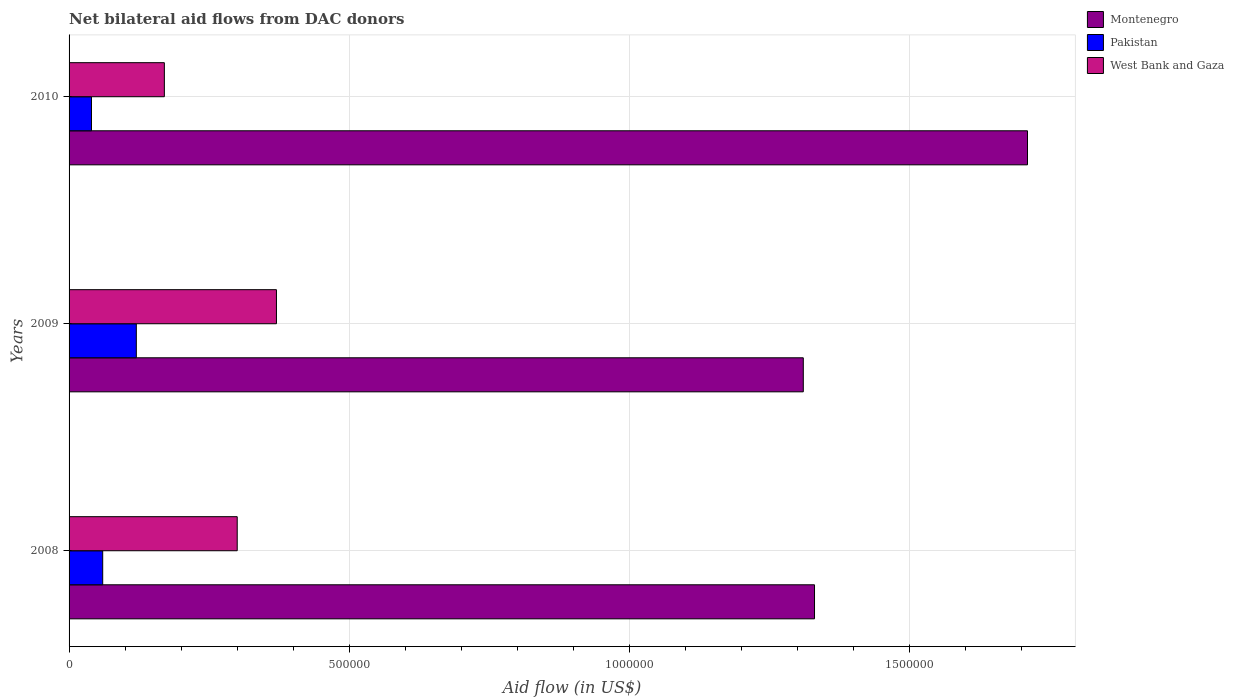How many groups of bars are there?
Offer a terse response. 3. Are the number of bars per tick equal to the number of legend labels?
Give a very brief answer. Yes. Are the number of bars on each tick of the Y-axis equal?
Offer a terse response. Yes. How many bars are there on the 3rd tick from the top?
Your response must be concise. 3. In how many cases, is the number of bars for a given year not equal to the number of legend labels?
Offer a very short reply. 0. What is the net bilateral aid flow in West Bank and Gaza in 2010?
Make the answer very short. 1.70e+05. Across all years, what is the maximum net bilateral aid flow in West Bank and Gaza?
Your answer should be compact. 3.70e+05. Across all years, what is the minimum net bilateral aid flow in Pakistan?
Your answer should be compact. 4.00e+04. In which year was the net bilateral aid flow in Pakistan maximum?
Offer a terse response. 2009. In which year was the net bilateral aid flow in West Bank and Gaza minimum?
Your response must be concise. 2010. What is the difference between the net bilateral aid flow in Pakistan in 2010 and the net bilateral aid flow in Montenegro in 2008?
Your answer should be very brief. -1.29e+06. What is the average net bilateral aid flow in Montenegro per year?
Your answer should be compact. 1.45e+06. In the year 2010, what is the difference between the net bilateral aid flow in West Bank and Gaza and net bilateral aid flow in Montenegro?
Give a very brief answer. -1.54e+06. What is the ratio of the net bilateral aid flow in Montenegro in 2009 to that in 2010?
Keep it short and to the point. 0.77. Is the difference between the net bilateral aid flow in West Bank and Gaza in 2008 and 2010 greater than the difference between the net bilateral aid flow in Montenegro in 2008 and 2010?
Your answer should be very brief. Yes. What is the difference between the highest and the second highest net bilateral aid flow in West Bank and Gaza?
Make the answer very short. 7.00e+04. What is the difference between the highest and the lowest net bilateral aid flow in Montenegro?
Provide a succinct answer. 4.00e+05. What does the 1st bar from the top in 2009 represents?
Your answer should be compact. West Bank and Gaza. Is it the case that in every year, the sum of the net bilateral aid flow in West Bank and Gaza and net bilateral aid flow in Pakistan is greater than the net bilateral aid flow in Montenegro?
Give a very brief answer. No. How many bars are there?
Keep it short and to the point. 9. Are all the bars in the graph horizontal?
Make the answer very short. Yes. What is the difference between two consecutive major ticks on the X-axis?
Your answer should be very brief. 5.00e+05. Are the values on the major ticks of X-axis written in scientific E-notation?
Your answer should be compact. No. How many legend labels are there?
Your answer should be compact. 3. How are the legend labels stacked?
Offer a terse response. Vertical. What is the title of the graph?
Make the answer very short. Net bilateral aid flows from DAC donors. Does "Burundi" appear as one of the legend labels in the graph?
Your answer should be very brief. No. What is the label or title of the X-axis?
Offer a terse response. Aid flow (in US$). What is the Aid flow (in US$) of Montenegro in 2008?
Provide a succinct answer. 1.33e+06. What is the Aid flow (in US$) in Pakistan in 2008?
Offer a terse response. 6.00e+04. What is the Aid flow (in US$) of Montenegro in 2009?
Keep it short and to the point. 1.31e+06. What is the Aid flow (in US$) in Pakistan in 2009?
Ensure brevity in your answer.  1.20e+05. What is the Aid flow (in US$) of West Bank and Gaza in 2009?
Provide a succinct answer. 3.70e+05. What is the Aid flow (in US$) in Montenegro in 2010?
Your answer should be very brief. 1.71e+06. What is the Aid flow (in US$) in West Bank and Gaza in 2010?
Your answer should be compact. 1.70e+05. Across all years, what is the maximum Aid flow (in US$) of Montenegro?
Your answer should be compact. 1.71e+06. Across all years, what is the maximum Aid flow (in US$) of Pakistan?
Provide a succinct answer. 1.20e+05. Across all years, what is the minimum Aid flow (in US$) of Montenegro?
Ensure brevity in your answer.  1.31e+06. Across all years, what is the minimum Aid flow (in US$) in Pakistan?
Your answer should be very brief. 4.00e+04. Across all years, what is the minimum Aid flow (in US$) in West Bank and Gaza?
Your response must be concise. 1.70e+05. What is the total Aid flow (in US$) of Montenegro in the graph?
Your answer should be very brief. 4.35e+06. What is the total Aid flow (in US$) in West Bank and Gaza in the graph?
Ensure brevity in your answer.  8.40e+05. What is the difference between the Aid flow (in US$) in Montenegro in 2008 and that in 2009?
Provide a succinct answer. 2.00e+04. What is the difference between the Aid flow (in US$) of West Bank and Gaza in 2008 and that in 2009?
Your response must be concise. -7.00e+04. What is the difference between the Aid flow (in US$) of Montenegro in 2008 and that in 2010?
Your answer should be compact. -3.80e+05. What is the difference between the Aid flow (in US$) of Pakistan in 2008 and that in 2010?
Provide a short and direct response. 2.00e+04. What is the difference between the Aid flow (in US$) in West Bank and Gaza in 2008 and that in 2010?
Offer a terse response. 1.30e+05. What is the difference between the Aid flow (in US$) of Montenegro in 2009 and that in 2010?
Make the answer very short. -4.00e+05. What is the difference between the Aid flow (in US$) of Pakistan in 2009 and that in 2010?
Provide a short and direct response. 8.00e+04. What is the difference between the Aid flow (in US$) in West Bank and Gaza in 2009 and that in 2010?
Make the answer very short. 2.00e+05. What is the difference between the Aid flow (in US$) in Montenegro in 2008 and the Aid flow (in US$) in Pakistan in 2009?
Offer a very short reply. 1.21e+06. What is the difference between the Aid flow (in US$) of Montenegro in 2008 and the Aid flow (in US$) of West Bank and Gaza in 2009?
Make the answer very short. 9.60e+05. What is the difference between the Aid flow (in US$) in Pakistan in 2008 and the Aid flow (in US$) in West Bank and Gaza in 2009?
Keep it short and to the point. -3.10e+05. What is the difference between the Aid flow (in US$) of Montenegro in 2008 and the Aid flow (in US$) of Pakistan in 2010?
Your response must be concise. 1.29e+06. What is the difference between the Aid flow (in US$) of Montenegro in 2008 and the Aid flow (in US$) of West Bank and Gaza in 2010?
Your response must be concise. 1.16e+06. What is the difference between the Aid flow (in US$) of Pakistan in 2008 and the Aid flow (in US$) of West Bank and Gaza in 2010?
Offer a terse response. -1.10e+05. What is the difference between the Aid flow (in US$) in Montenegro in 2009 and the Aid flow (in US$) in Pakistan in 2010?
Give a very brief answer. 1.27e+06. What is the difference between the Aid flow (in US$) in Montenegro in 2009 and the Aid flow (in US$) in West Bank and Gaza in 2010?
Provide a short and direct response. 1.14e+06. What is the difference between the Aid flow (in US$) in Pakistan in 2009 and the Aid flow (in US$) in West Bank and Gaza in 2010?
Your answer should be compact. -5.00e+04. What is the average Aid flow (in US$) of Montenegro per year?
Your response must be concise. 1.45e+06. What is the average Aid flow (in US$) in Pakistan per year?
Your response must be concise. 7.33e+04. What is the average Aid flow (in US$) of West Bank and Gaza per year?
Your answer should be compact. 2.80e+05. In the year 2008, what is the difference between the Aid flow (in US$) of Montenegro and Aid flow (in US$) of Pakistan?
Give a very brief answer. 1.27e+06. In the year 2008, what is the difference between the Aid flow (in US$) of Montenegro and Aid flow (in US$) of West Bank and Gaza?
Provide a succinct answer. 1.03e+06. In the year 2009, what is the difference between the Aid flow (in US$) in Montenegro and Aid flow (in US$) in Pakistan?
Make the answer very short. 1.19e+06. In the year 2009, what is the difference between the Aid flow (in US$) in Montenegro and Aid flow (in US$) in West Bank and Gaza?
Give a very brief answer. 9.40e+05. In the year 2009, what is the difference between the Aid flow (in US$) of Pakistan and Aid flow (in US$) of West Bank and Gaza?
Your response must be concise. -2.50e+05. In the year 2010, what is the difference between the Aid flow (in US$) of Montenegro and Aid flow (in US$) of Pakistan?
Make the answer very short. 1.67e+06. In the year 2010, what is the difference between the Aid flow (in US$) in Montenegro and Aid flow (in US$) in West Bank and Gaza?
Provide a succinct answer. 1.54e+06. What is the ratio of the Aid flow (in US$) in Montenegro in 2008 to that in 2009?
Offer a very short reply. 1.02. What is the ratio of the Aid flow (in US$) in West Bank and Gaza in 2008 to that in 2009?
Provide a succinct answer. 0.81. What is the ratio of the Aid flow (in US$) of Pakistan in 2008 to that in 2010?
Your answer should be very brief. 1.5. What is the ratio of the Aid flow (in US$) in West Bank and Gaza in 2008 to that in 2010?
Make the answer very short. 1.76. What is the ratio of the Aid flow (in US$) of Montenegro in 2009 to that in 2010?
Your answer should be compact. 0.77. What is the ratio of the Aid flow (in US$) of West Bank and Gaza in 2009 to that in 2010?
Provide a succinct answer. 2.18. What is the difference between the highest and the second highest Aid flow (in US$) in West Bank and Gaza?
Your response must be concise. 7.00e+04. What is the difference between the highest and the lowest Aid flow (in US$) of Pakistan?
Provide a short and direct response. 8.00e+04. What is the difference between the highest and the lowest Aid flow (in US$) in West Bank and Gaza?
Your answer should be compact. 2.00e+05. 